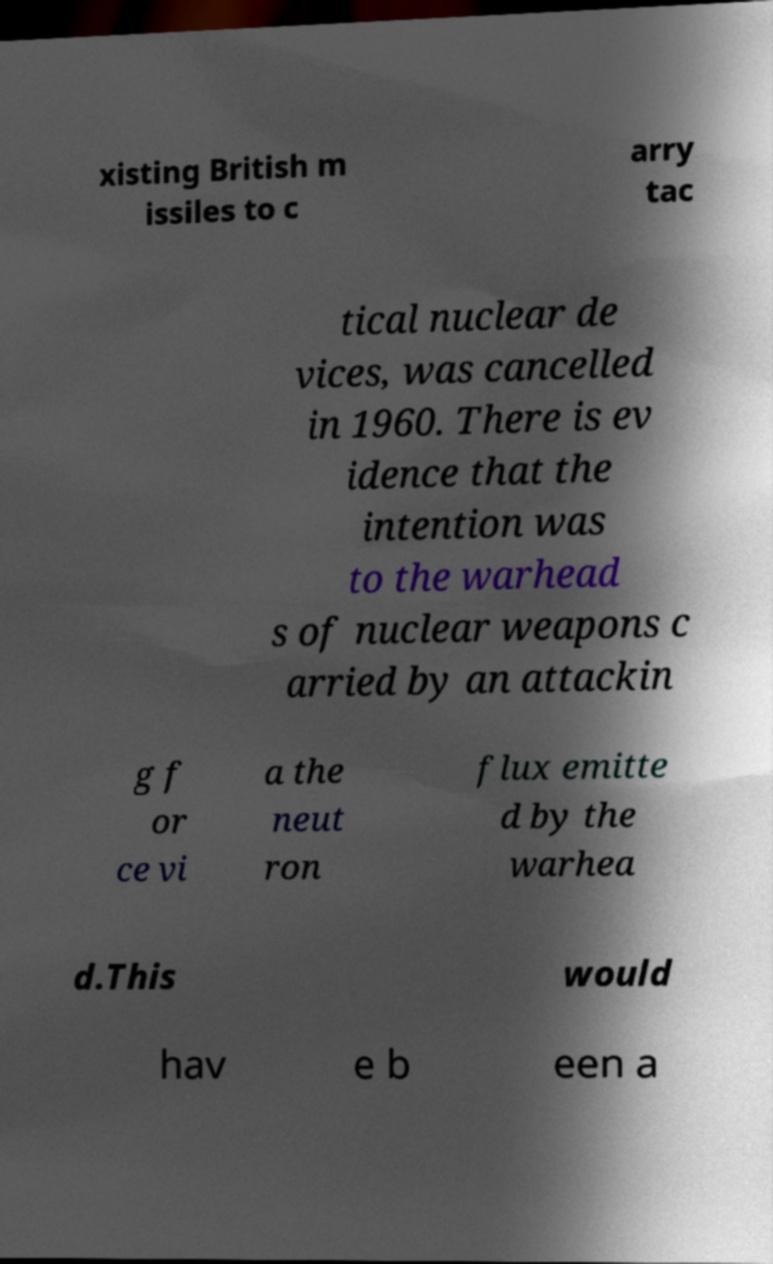For documentation purposes, I need the text within this image transcribed. Could you provide that? xisting British m issiles to c arry tac tical nuclear de vices, was cancelled in 1960. There is ev idence that the intention was to the warhead s of nuclear weapons c arried by an attackin g f or ce vi a the neut ron flux emitte d by the warhea d.This would hav e b een a 